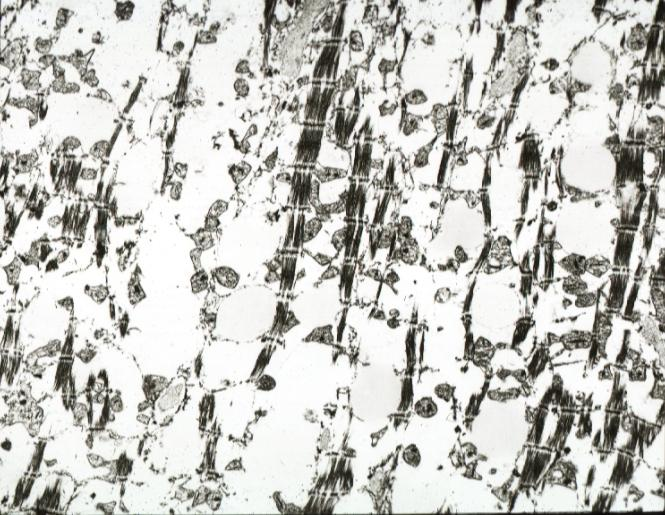what does myocytolysis not show containing no lipid?
Answer the question using a single word or phrase. Show lesion 